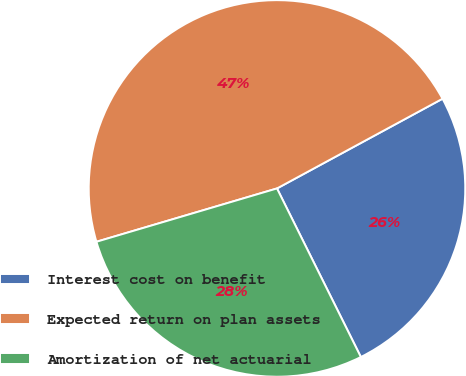<chart> <loc_0><loc_0><loc_500><loc_500><pie_chart><fcel>Interest cost on benefit<fcel>Expected return on plan assets<fcel>Amortization of net actuarial<nl><fcel>25.56%<fcel>46.67%<fcel>27.78%<nl></chart> 